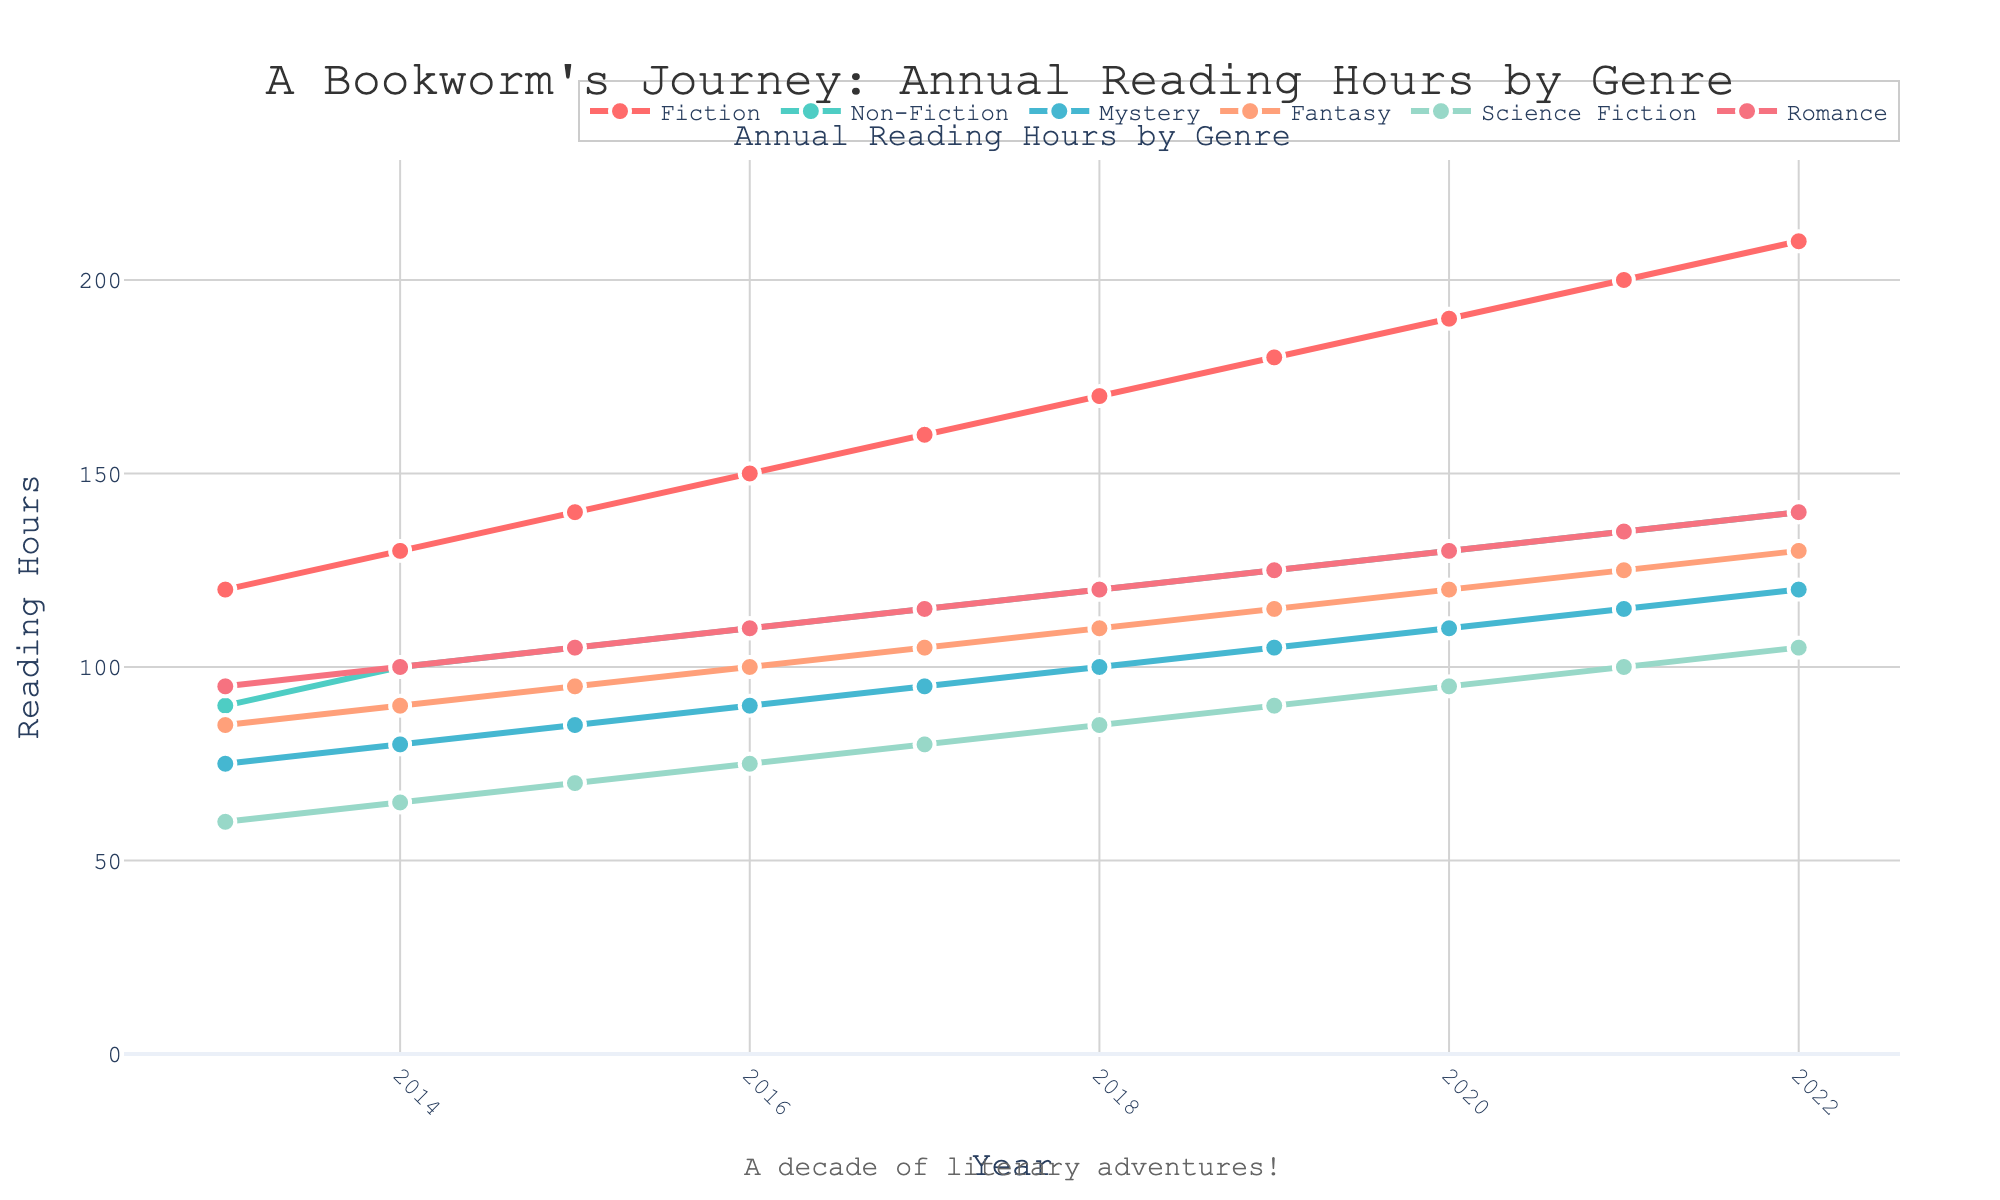What is the title of the plot? The title is displayed at the top of the plot. It reads "A Bookworm's Journey: Annual Reading Hours by Genre."
Answer: A Bookworm's Journey: Annual Reading Hours by Genre How many different genres are plotted on the chart? By looking at the legend or the lines representing different genres, we can count that there are six different genres: Fiction, Non-Fiction, Mystery, Fantasy, Science Fiction, and Romance.
Answer: Six Between which years does the data range? The x-axis signifies the years, starting from 2013 and going up to 2022.
Answer: 2013 to 2022 Which genre had the highest reading hours in 2022? The highest value for 2022 on the y-axis corresponds to the genre "Fiction" as per the legend.
Answer: Fiction How many reading hours did Mystery have in 2018? Locate the year 2018 on the x-axis, then follow up to the point for “Mystery” using the legend or color-coding, which is 100 hours.
Answer: 100 What is the overall trend of reading hours for the Fantasy genre over the years? Observe the line plot for Fantasy; it shows a steady increase in reading hours from 2013 to 2022.
Answer: Increasing In which year did Fiction surpass 150 reading hours? Follow the Fiction line starting from 2013 until it crosses the 150-hour mark on the y-axis, which occurs in 2016.
Answer: 2016 Compare the reading hours of Non-Fiction and Science Fiction for the year 2020. Which genre had more reading hours and by how much? For 2020, Non-Fiction had 130 hours while Science Fiction had 95 hours. The difference is 130 - 95 = 35 hours.
Answer: Non-Fiction by 35 hours Which genre had the smallest increase in reading hours from 2013 to 2022? Calculate the difference between 2022 and 2013 for each genre and observe that Science Fiction increased from 60 to 105, the smallest increase of 45 hours.
Answer: Science Fiction What is the average reading hours across all genres in the year 2019? Sum the hours for all genres in 2019: 180 + 125 + 105 + 115 + 90 + 125 = 740, then divide by number of genres, 740 / 6 ≈ 123.33.
Answer: About 123.33 